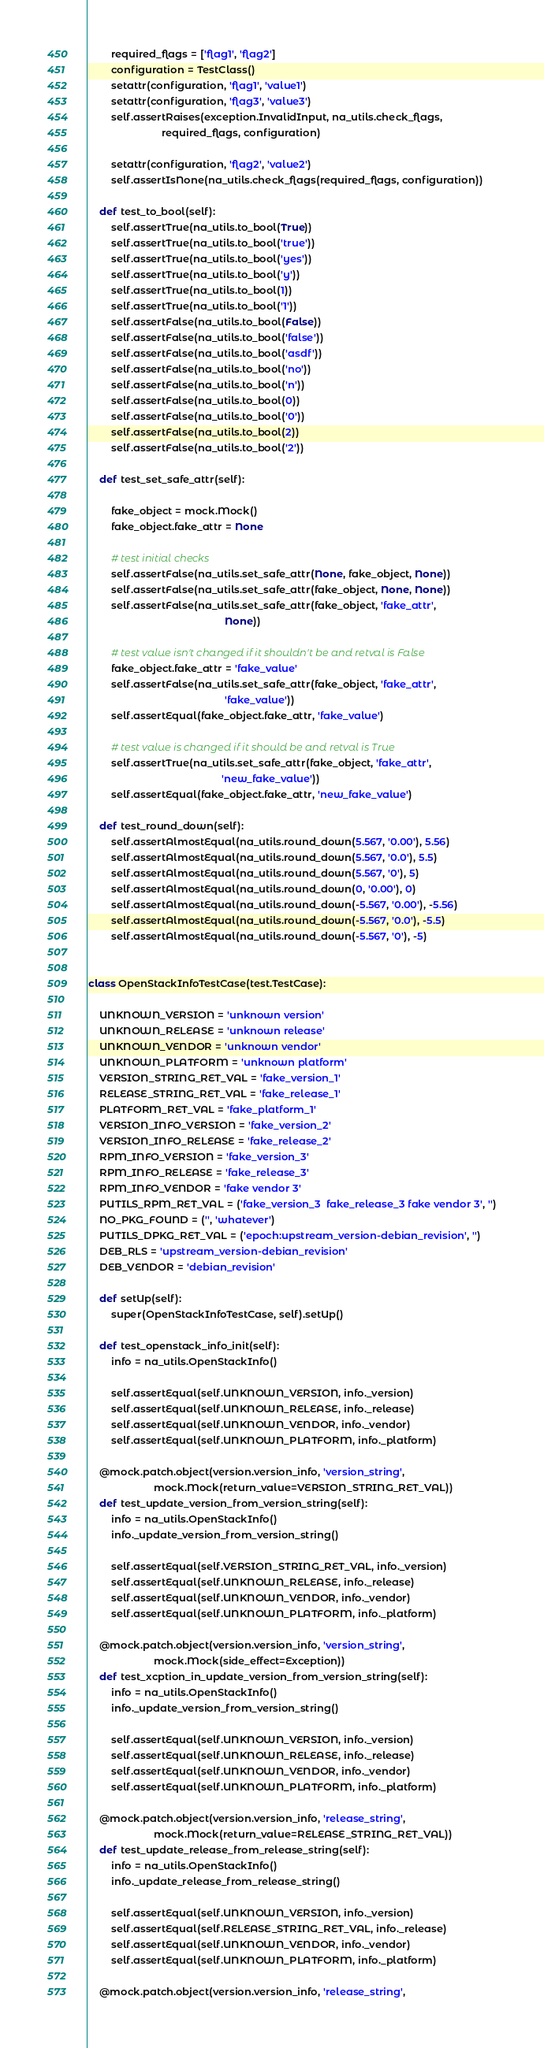Convert code to text. <code><loc_0><loc_0><loc_500><loc_500><_Python_>        required_flags = ['flag1', 'flag2']
        configuration = TestClass()
        setattr(configuration, 'flag1', 'value1')
        setattr(configuration, 'flag3', 'value3')
        self.assertRaises(exception.InvalidInput, na_utils.check_flags,
                          required_flags, configuration)

        setattr(configuration, 'flag2', 'value2')
        self.assertIsNone(na_utils.check_flags(required_flags, configuration))

    def test_to_bool(self):
        self.assertTrue(na_utils.to_bool(True))
        self.assertTrue(na_utils.to_bool('true'))
        self.assertTrue(na_utils.to_bool('yes'))
        self.assertTrue(na_utils.to_bool('y'))
        self.assertTrue(na_utils.to_bool(1))
        self.assertTrue(na_utils.to_bool('1'))
        self.assertFalse(na_utils.to_bool(False))
        self.assertFalse(na_utils.to_bool('false'))
        self.assertFalse(na_utils.to_bool('asdf'))
        self.assertFalse(na_utils.to_bool('no'))
        self.assertFalse(na_utils.to_bool('n'))
        self.assertFalse(na_utils.to_bool(0))
        self.assertFalse(na_utils.to_bool('0'))
        self.assertFalse(na_utils.to_bool(2))
        self.assertFalse(na_utils.to_bool('2'))

    def test_set_safe_attr(self):

        fake_object = mock.Mock()
        fake_object.fake_attr = None

        # test initial checks
        self.assertFalse(na_utils.set_safe_attr(None, fake_object, None))
        self.assertFalse(na_utils.set_safe_attr(fake_object, None, None))
        self.assertFalse(na_utils.set_safe_attr(fake_object, 'fake_attr',
                                                None))

        # test value isn't changed if it shouldn't be and retval is False
        fake_object.fake_attr = 'fake_value'
        self.assertFalse(na_utils.set_safe_attr(fake_object, 'fake_attr',
                                                'fake_value'))
        self.assertEqual(fake_object.fake_attr, 'fake_value')

        # test value is changed if it should be and retval is True
        self.assertTrue(na_utils.set_safe_attr(fake_object, 'fake_attr',
                                               'new_fake_value'))
        self.assertEqual(fake_object.fake_attr, 'new_fake_value')

    def test_round_down(self):
        self.assertAlmostEqual(na_utils.round_down(5.567, '0.00'), 5.56)
        self.assertAlmostEqual(na_utils.round_down(5.567, '0.0'), 5.5)
        self.assertAlmostEqual(na_utils.round_down(5.567, '0'), 5)
        self.assertAlmostEqual(na_utils.round_down(0, '0.00'), 0)
        self.assertAlmostEqual(na_utils.round_down(-5.567, '0.00'), -5.56)
        self.assertAlmostEqual(na_utils.round_down(-5.567, '0.0'), -5.5)
        self.assertAlmostEqual(na_utils.round_down(-5.567, '0'), -5)


class OpenStackInfoTestCase(test.TestCase):

    UNKNOWN_VERSION = 'unknown version'
    UNKNOWN_RELEASE = 'unknown release'
    UNKNOWN_VENDOR = 'unknown vendor'
    UNKNOWN_PLATFORM = 'unknown platform'
    VERSION_STRING_RET_VAL = 'fake_version_1'
    RELEASE_STRING_RET_VAL = 'fake_release_1'
    PLATFORM_RET_VAL = 'fake_platform_1'
    VERSION_INFO_VERSION = 'fake_version_2'
    VERSION_INFO_RELEASE = 'fake_release_2'
    RPM_INFO_VERSION = 'fake_version_3'
    RPM_INFO_RELEASE = 'fake_release_3'
    RPM_INFO_VENDOR = 'fake vendor 3'
    PUTILS_RPM_RET_VAL = ('fake_version_3  fake_release_3 fake vendor 3', '')
    NO_PKG_FOUND = ('', 'whatever')
    PUTILS_DPKG_RET_VAL = ('epoch:upstream_version-debian_revision', '')
    DEB_RLS = 'upstream_version-debian_revision'
    DEB_VENDOR = 'debian_revision'

    def setUp(self):
        super(OpenStackInfoTestCase, self).setUp()

    def test_openstack_info_init(self):
        info = na_utils.OpenStackInfo()

        self.assertEqual(self.UNKNOWN_VERSION, info._version)
        self.assertEqual(self.UNKNOWN_RELEASE, info._release)
        self.assertEqual(self.UNKNOWN_VENDOR, info._vendor)
        self.assertEqual(self.UNKNOWN_PLATFORM, info._platform)

    @mock.patch.object(version.version_info, 'version_string',
                       mock.Mock(return_value=VERSION_STRING_RET_VAL))
    def test_update_version_from_version_string(self):
        info = na_utils.OpenStackInfo()
        info._update_version_from_version_string()

        self.assertEqual(self.VERSION_STRING_RET_VAL, info._version)
        self.assertEqual(self.UNKNOWN_RELEASE, info._release)
        self.assertEqual(self.UNKNOWN_VENDOR, info._vendor)
        self.assertEqual(self.UNKNOWN_PLATFORM, info._platform)

    @mock.patch.object(version.version_info, 'version_string',
                       mock.Mock(side_effect=Exception))
    def test_xcption_in_update_version_from_version_string(self):
        info = na_utils.OpenStackInfo()
        info._update_version_from_version_string()

        self.assertEqual(self.UNKNOWN_VERSION, info._version)
        self.assertEqual(self.UNKNOWN_RELEASE, info._release)
        self.assertEqual(self.UNKNOWN_VENDOR, info._vendor)
        self.assertEqual(self.UNKNOWN_PLATFORM, info._platform)

    @mock.patch.object(version.version_info, 'release_string',
                       mock.Mock(return_value=RELEASE_STRING_RET_VAL))
    def test_update_release_from_release_string(self):
        info = na_utils.OpenStackInfo()
        info._update_release_from_release_string()

        self.assertEqual(self.UNKNOWN_VERSION, info._version)
        self.assertEqual(self.RELEASE_STRING_RET_VAL, info._release)
        self.assertEqual(self.UNKNOWN_VENDOR, info._vendor)
        self.assertEqual(self.UNKNOWN_PLATFORM, info._platform)

    @mock.patch.object(version.version_info, 'release_string',</code> 